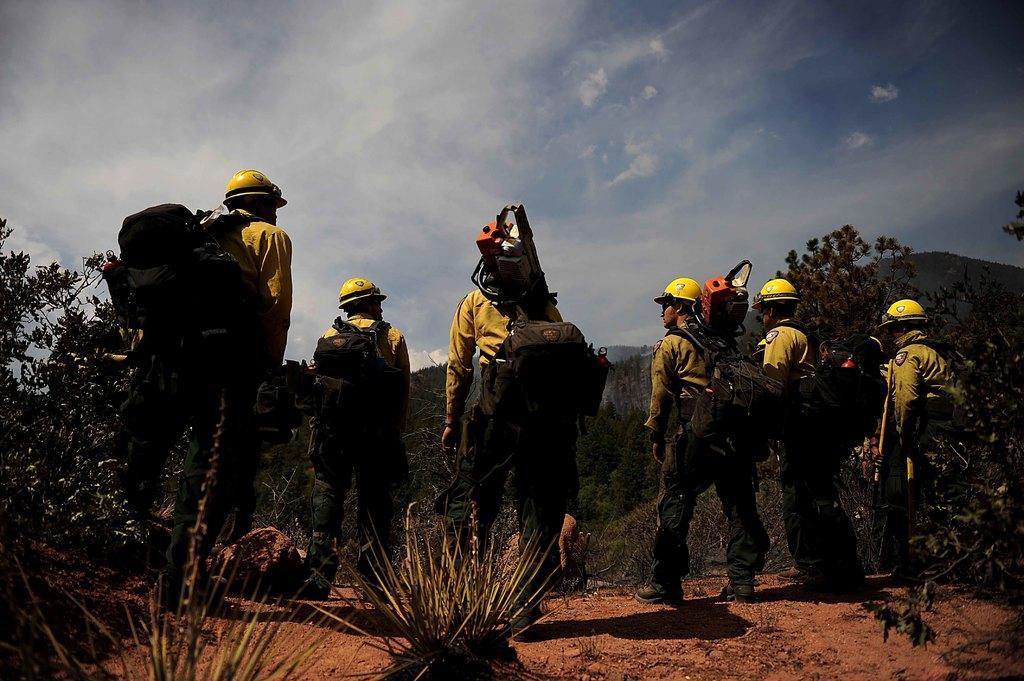Could you give a brief overview of what you see in this image? In this image we can see men standing on the ground and wearing backpacks. In the background there are hills, trees, shrubs, stones and sky with clouds. 